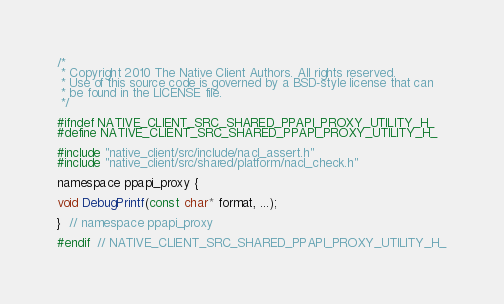Convert code to text. <code><loc_0><loc_0><loc_500><loc_500><_C_>/*
 * Copyright 2010 The Native Client Authors. All rights reserved.
 * Use of this source code is governed by a BSD-style license that can
 * be found in the LICENSE file.
 */

#ifndef NATIVE_CLIENT_SRC_SHARED_PPAPI_PROXY_UTILITY_H_
#define NATIVE_CLIENT_SRC_SHARED_PPAPI_PROXY_UTILITY_H_

#include "native_client/src/include/nacl_assert.h"
#include "native_client/src/shared/platform/nacl_check.h"

namespace ppapi_proxy {

void DebugPrintf(const char* format, ...);

}  // namespace ppapi_proxy

#endif  // NATIVE_CLIENT_SRC_SHARED_PPAPI_PROXY_UTILITY_H_
</code> 